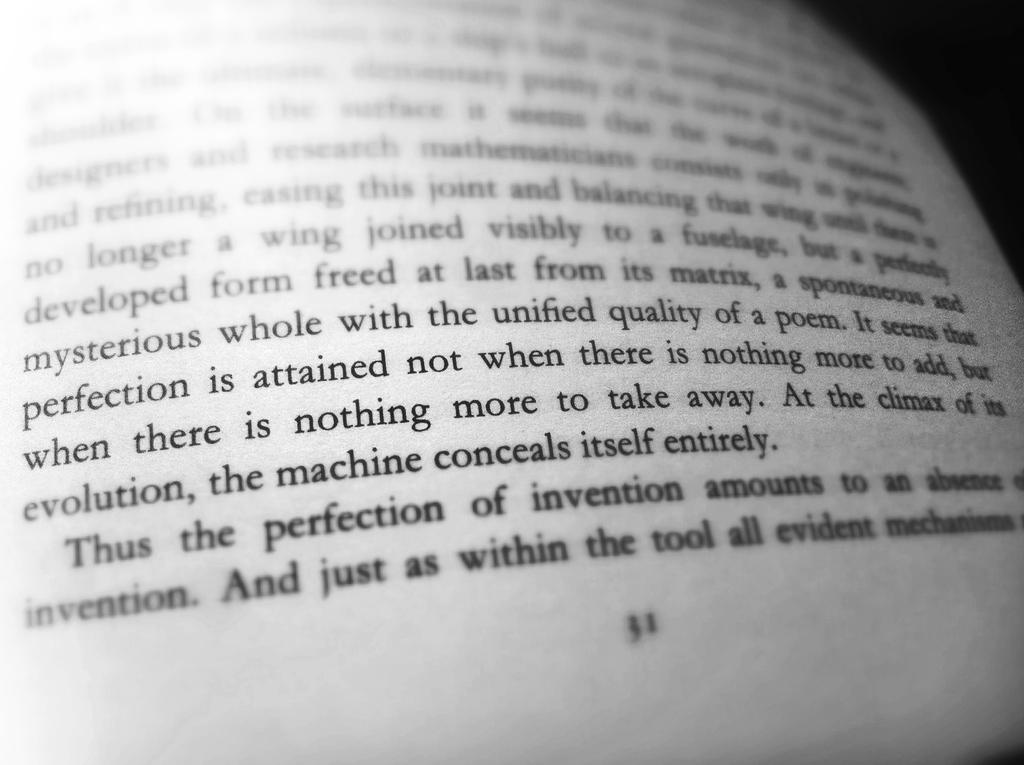<image>
Describe the image concisely. A book is opened to show the text contained on page 31. 